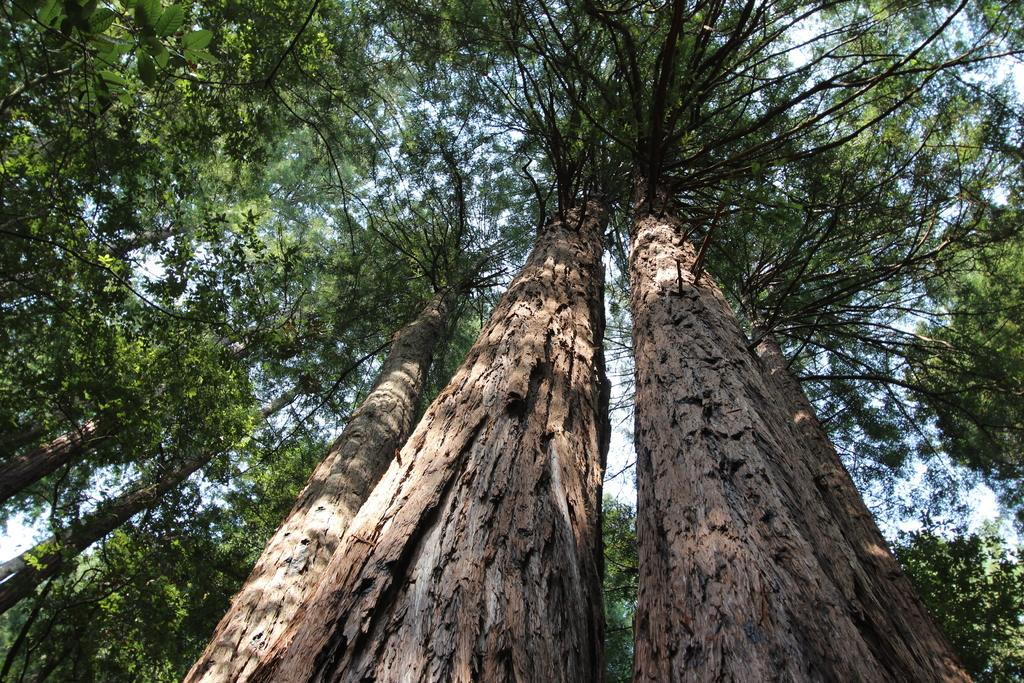What type of vegetation can be seen in the image? There are trees in the image. What part of the natural environment is visible in the image? The sky is visible in the background of the image. Can you see any birds in the image? There is no mention of birds in the image, so it cannot be determined if any are present. Is this image taken during a vacation? The image does not provide any information about the context or purpose of the scene, so it cannot be determined if it was taken during a vacation. 